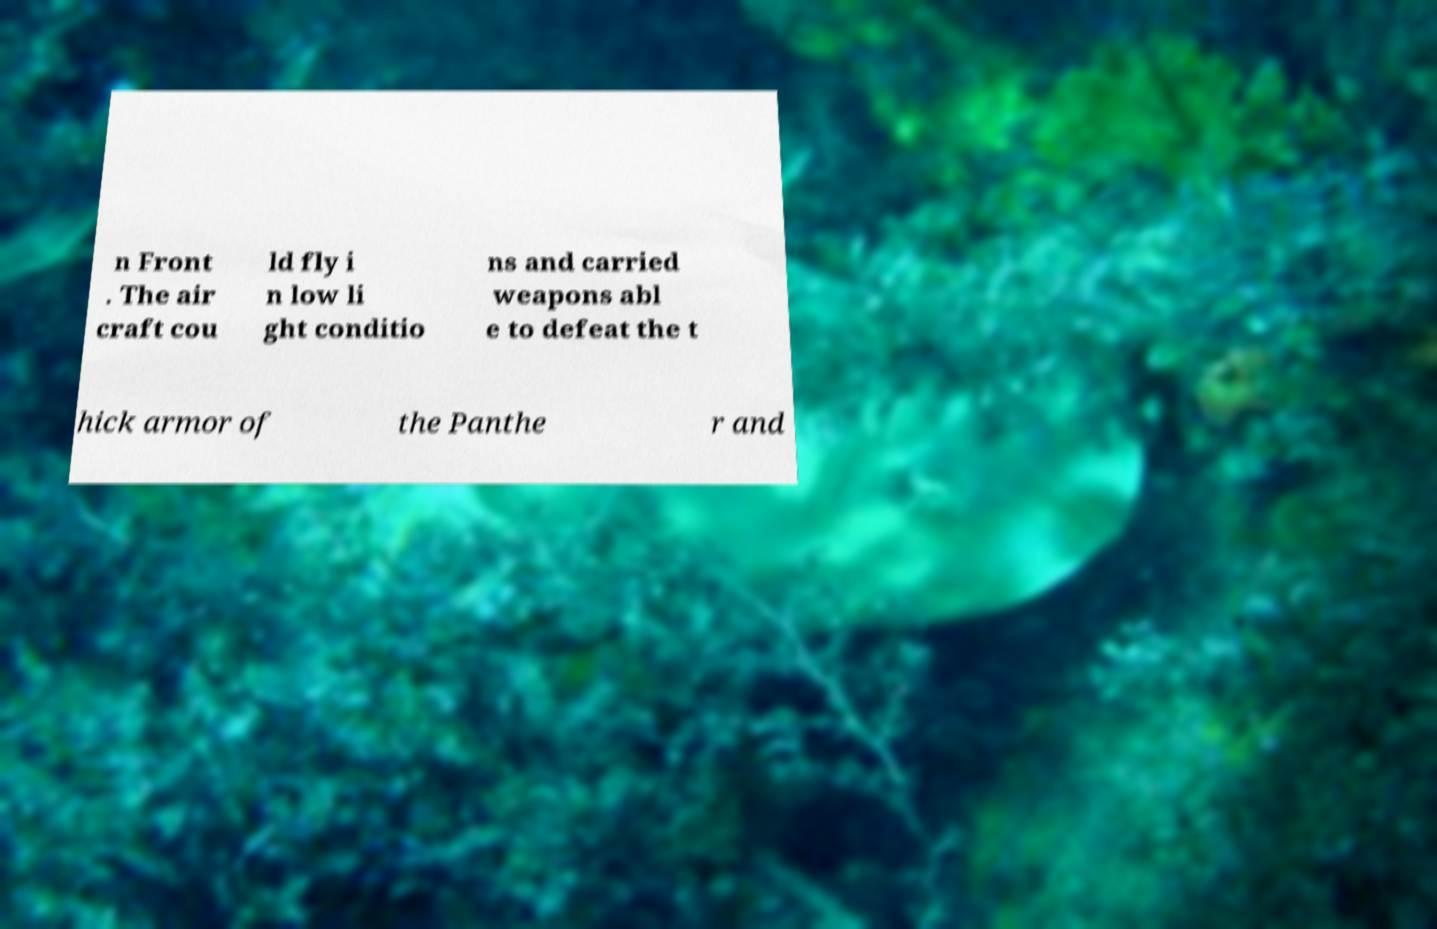What messages or text are displayed in this image? I need them in a readable, typed format. n Front . The air craft cou ld fly i n low li ght conditio ns and carried weapons abl e to defeat the t hick armor of the Panthe r and 